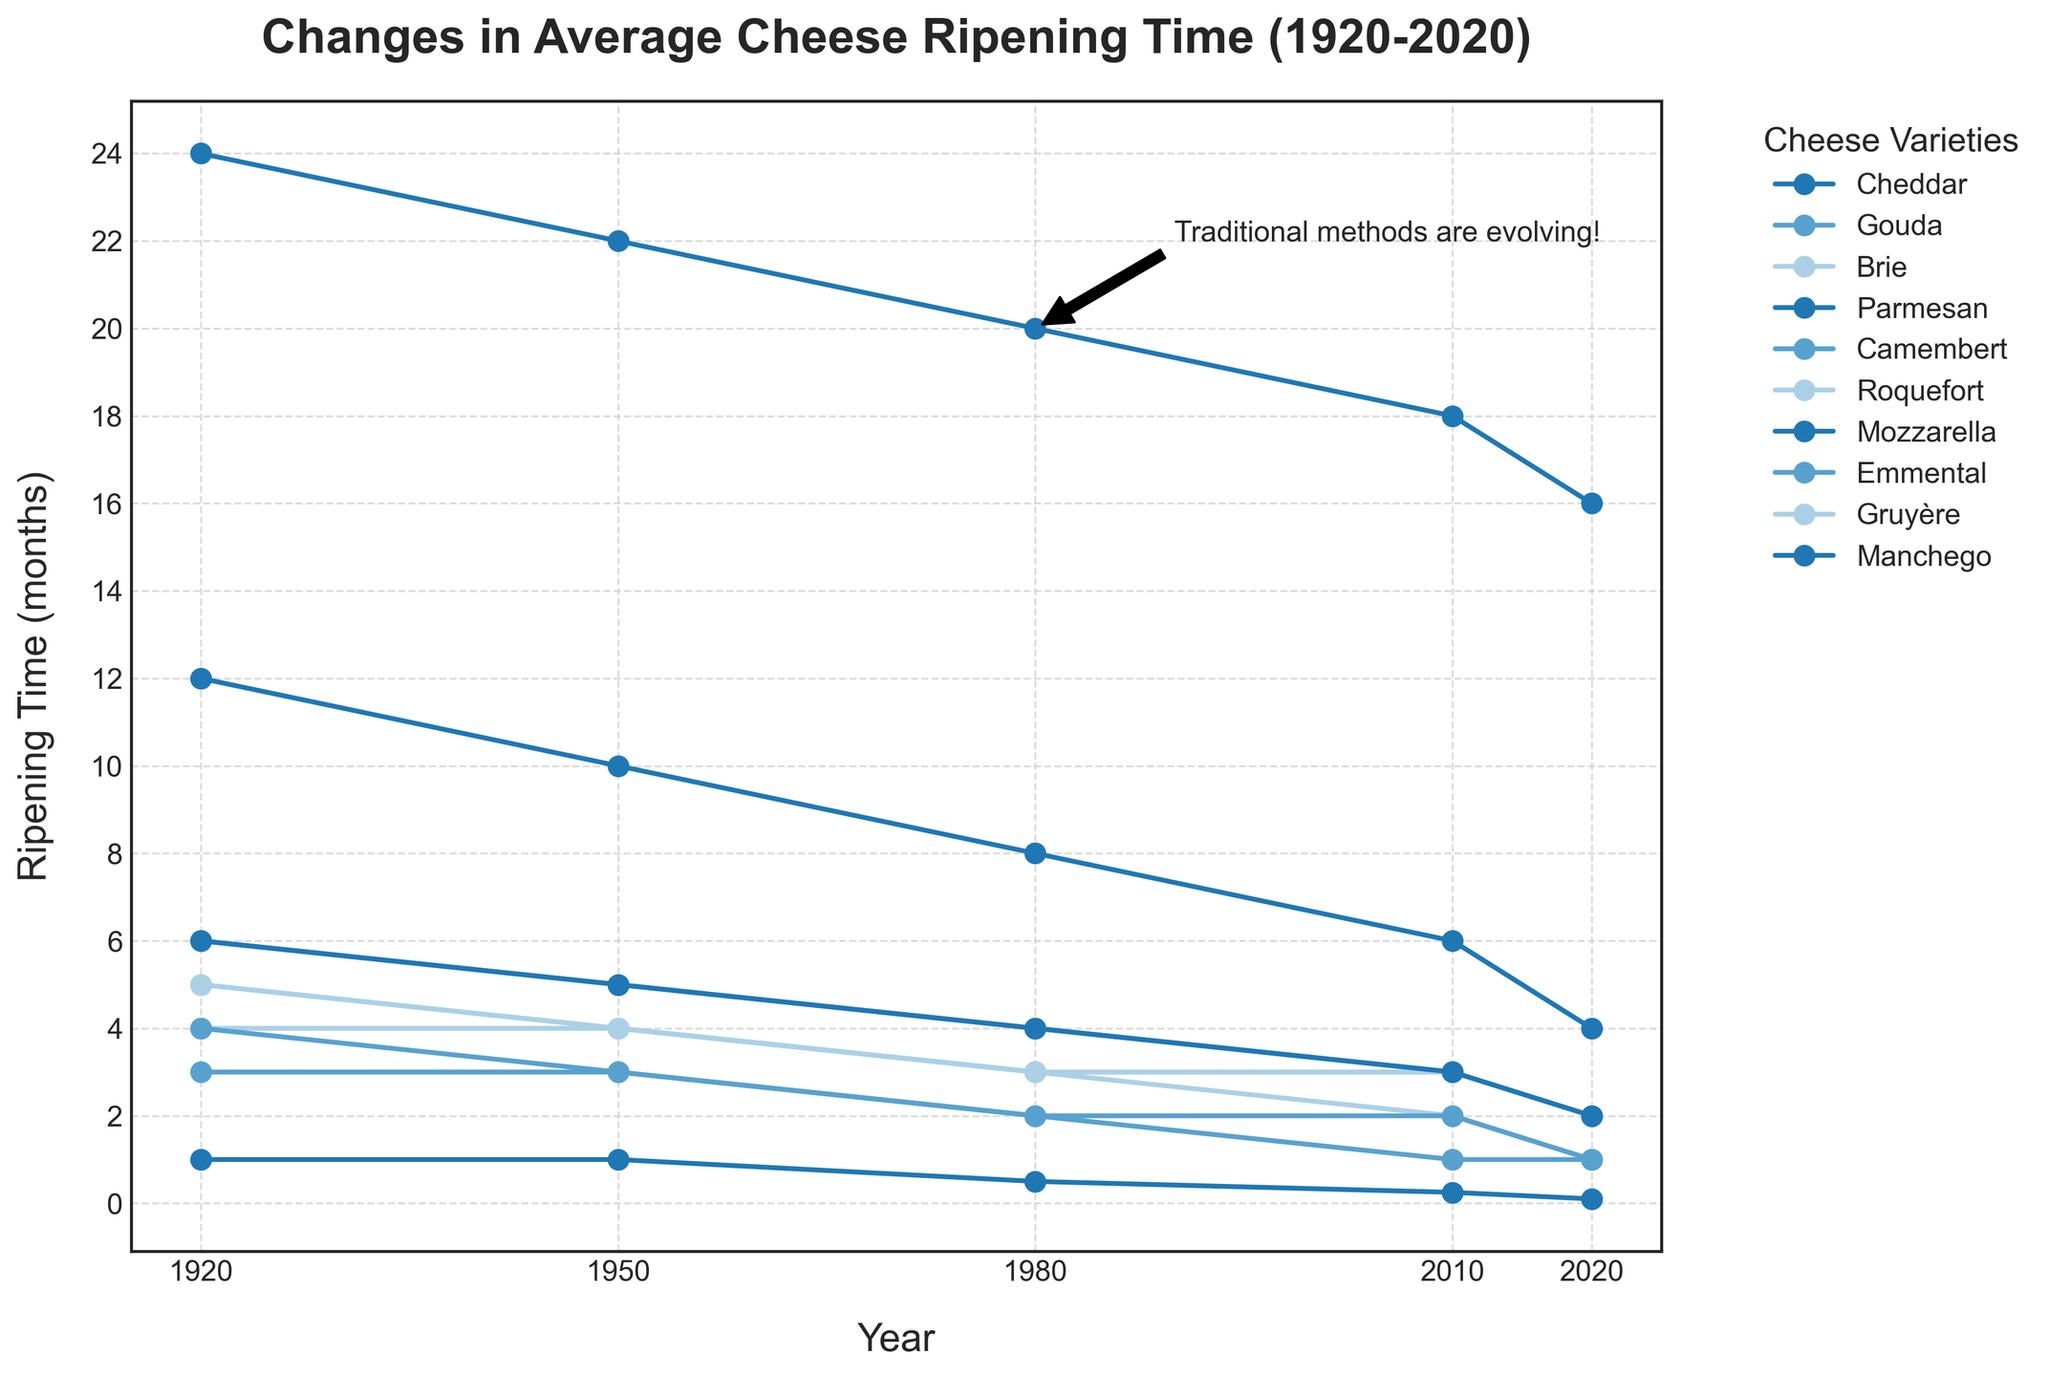What cheese variety has the least reduction in ripening time from 1920 to 2020? First, identify the start and end time for each cheese variety. Calculate the difference by subtracting the 2020 value from the 1920 value for each variety. Identify the cheese with the smallest difference. The smallest reduction in ripening time occurs for Camembert, going from 3 months to 1 month, a reduction of 2 months.
Answer: Camembert Which cheese had the fastest decrease in ripening time from 1920 to 2020? Identify each cheese variety's ripening time in 1920 and 2020, then calculate the difference by subtracting the 2020 value from the 1920 value. Compare these reductions to determine the largest difference. Mozzarella has the fastest decrease, from 1 month in 1920 to 0.1 months in 2020, a reduction of 0.9 months.
Answer: Mozzarella In what decade did Cheddar's ripening time have the most significant decrease? Track the changes in Cheddar's ripening time across the decades: 1920-1950, 1950-1980, 1980-2010, 2010-2020. Calculate the decrease for each interval. The most significant decrease occurred between 2010 and 2020, where ripening time dropped from 6 months to 4 months, a reduction of 2 months.
Answer: 2010-2020 Which cheese variety has the longest ripening time in 2020? Look at the ripening time for all cheese varieties in 2020. The one with the highest value is Parmesan, with a ripening time of 16 months.
Answer: Parmesan What's the total decrease in ripening time for all cheese varieties combined from 1920 to 2020? Calculate the decrease for each variety by subtracting the 2020 value from the 1920 value and then sum these values. \[
\begin{aligned}
& \text{Cheddar}: 12 - 4 = 8 \\
& \text{Gouda}: 6 - 2 = 4 \\
& \text{Brie}: 4 - 1 = 3 \\
& \text{Parmesan}: 24 - 16 = 8 \\
& \text{Camembert}: 3 - 1 = 2 \\
& \text{Roquefort}: 5 - 2 = 3 \\
& \text{Mozzarella}: 1 - 0.1 = 0.9 \\
& \text{Emmental}: 4 - 1 = 3 \\
& \text{Gruyère}: 5 - 2 = 3 \\
& \text{Manchego}: 6 - 2 = 4 \\
& \text{Total Decrease}: 8 + 4 + 3 + 8 + 2 + 3 + 0.9 + 3 + 3 + 4 = 38.9
\end{aligned}
\]
Answer: 38.9 How does the ripening time of Parmesan in 1920 compare to that of Gouda in 1950? Look at the ripening times in the table: Parmesan in 1920 has a ripening time of 24 months, and Gouda in 1950 has a ripening time of 5 months. Comparing these numbers shows that Parmesan in 1920 ripens much longer than Gouda in 1950.
Answer: Parmesan in 1920 is longer Which two cheese varieties have equal ripening times in any given year? Scan the values in the table to find any matching ripening times for the same year. In 1950, both Brie and Camembert have a ripening time of 4 months.
Answer: Brie and Camembert in 1950 